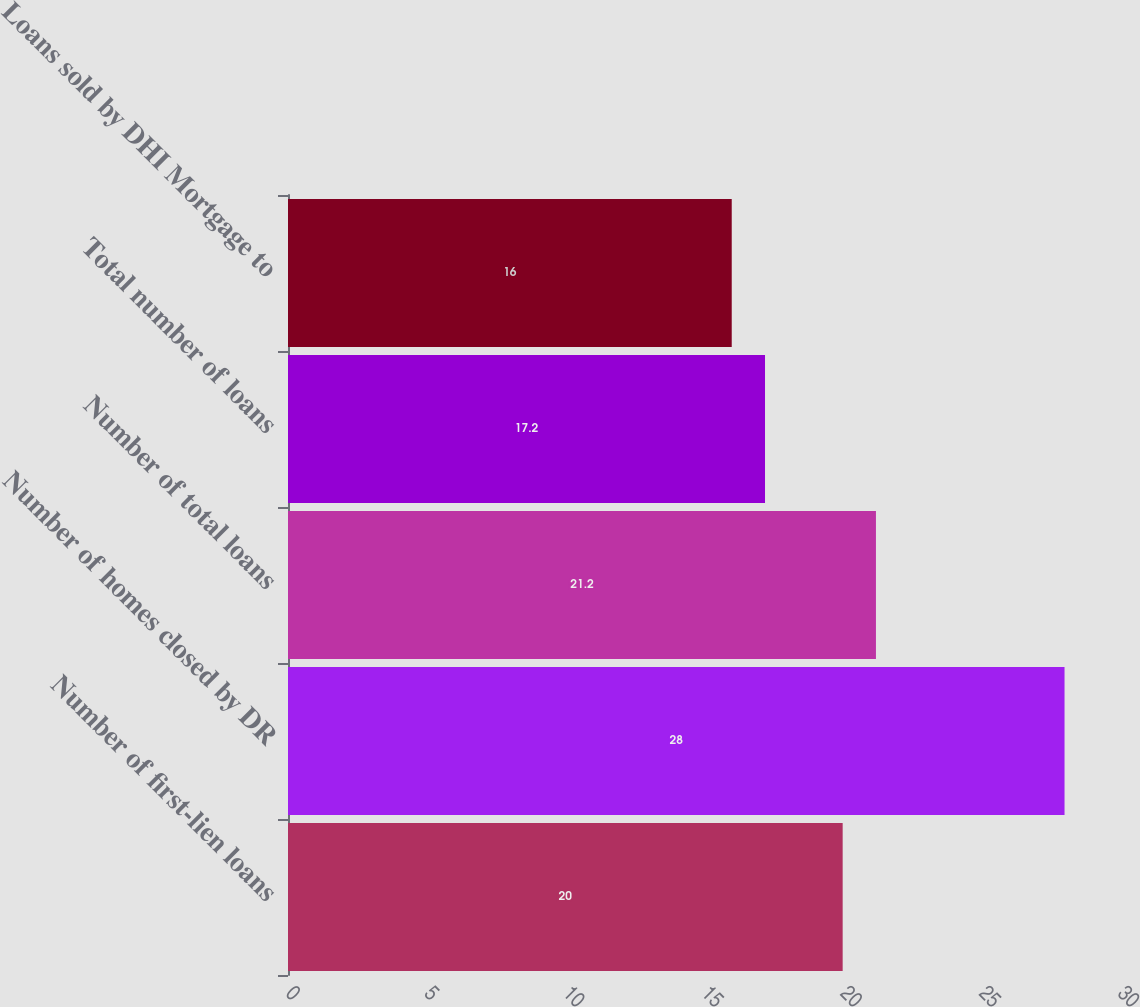Convert chart to OTSL. <chart><loc_0><loc_0><loc_500><loc_500><bar_chart><fcel>Number of first-lien loans<fcel>Number of homes closed by DR<fcel>Number of total loans<fcel>Total number of loans<fcel>Loans sold by DHI Mortgage to<nl><fcel>20<fcel>28<fcel>21.2<fcel>17.2<fcel>16<nl></chart> 